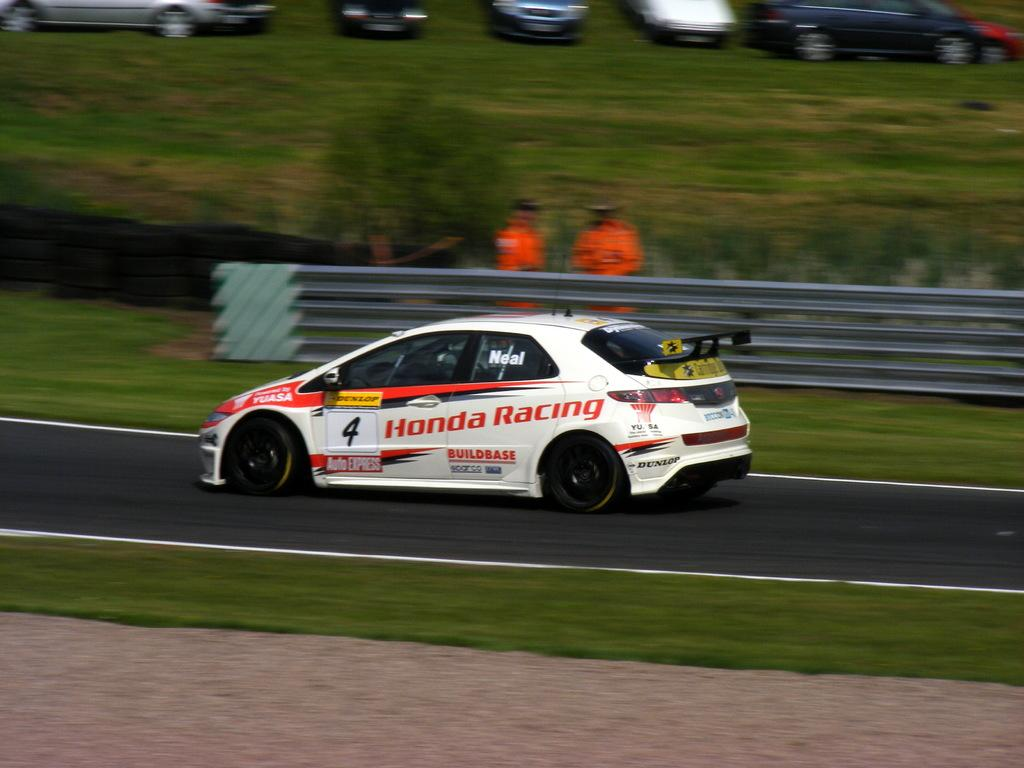<image>
Summarize the visual content of the image. Red and white racing car that says "Honda Racing" on the side. 